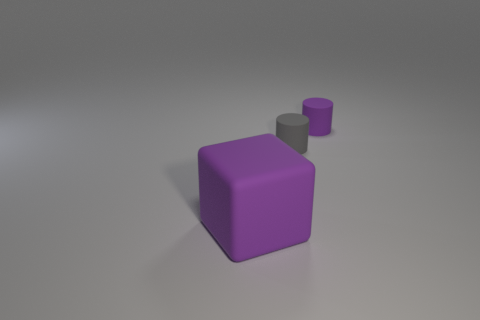Add 3 small cyan blocks. How many objects exist? 6 Subtract all cylinders. How many objects are left? 1 Add 1 gray metallic balls. How many gray metallic balls exist? 1 Subtract 0 blue balls. How many objects are left? 3 Subtract all large things. Subtract all small gray objects. How many objects are left? 1 Add 3 small rubber objects. How many small rubber objects are left? 5 